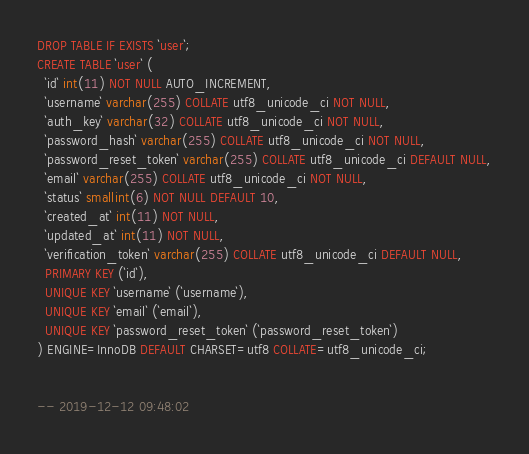<code> <loc_0><loc_0><loc_500><loc_500><_SQL_>
DROP TABLE IF EXISTS `user`;
CREATE TABLE `user` (
  `id` int(11) NOT NULL AUTO_INCREMENT,
  `username` varchar(255) COLLATE utf8_unicode_ci NOT NULL,
  `auth_key` varchar(32) COLLATE utf8_unicode_ci NOT NULL,
  `password_hash` varchar(255) COLLATE utf8_unicode_ci NOT NULL,
  `password_reset_token` varchar(255) COLLATE utf8_unicode_ci DEFAULT NULL,
  `email` varchar(255) COLLATE utf8_unicode_ci NOT NULL,
  `status` smallint(6) NOT NULL DEFAULT 10,
  `created_at` int(11) NOT NULL,
  `updated_at` int(11) NOT NULL,
  `verification_token` varchar(255) COLLATE utf8_unicode_ci DEFAULT NULL,
  PRIMARY KEY (`id`),
  UNIQUE KEY `username` (`username`),
  UNIQUE KEY `email` (`email`),
  UNIQUE KEY `password_reset_token` (`password_reset_token`)
) ENGINE=InnoDB DEFAULT CHARSET=utf8 COLLATE=utf8_unicode_ci;


-- 2019-12-12 09:48:02
</code> 